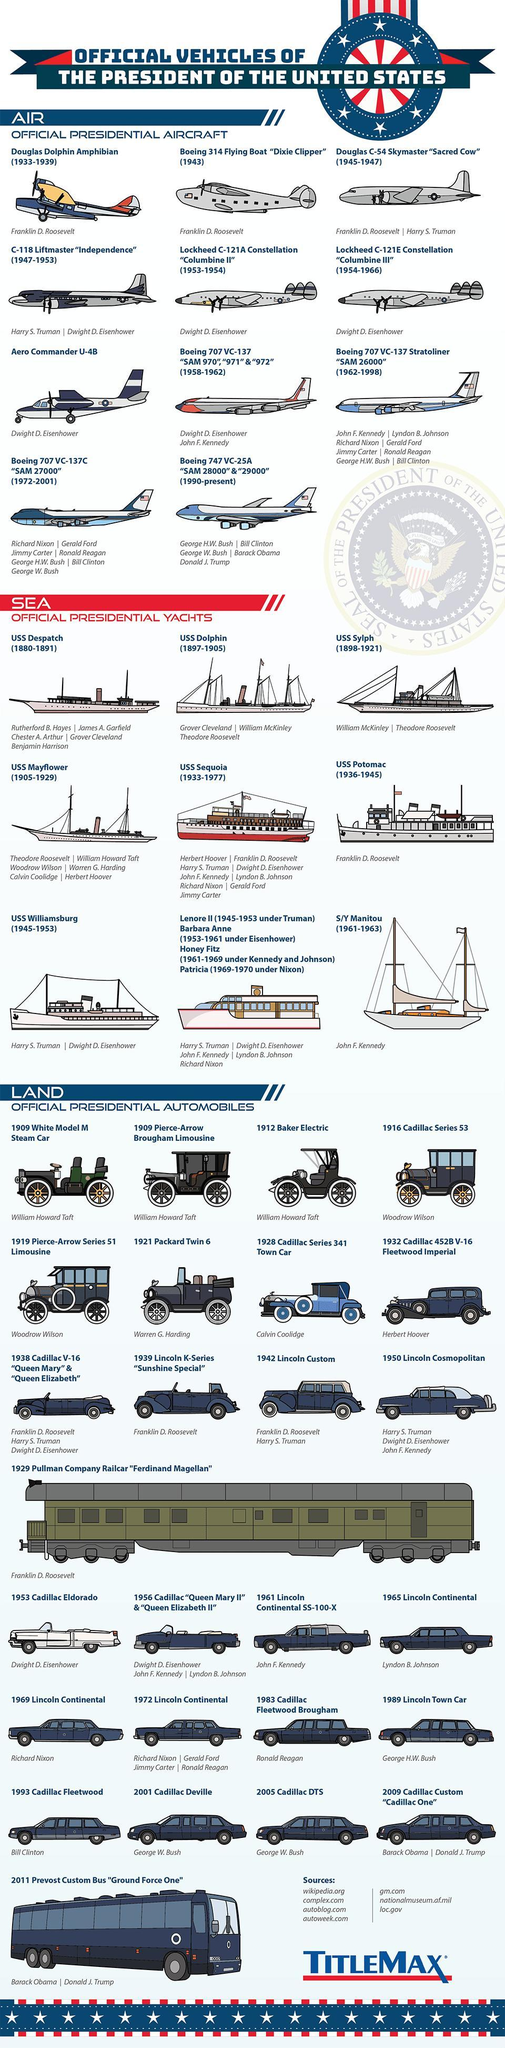Which yacht was shared by Harry S. Truman and Dwight D. Eisenhower?
Answer the question with a short phrase. USS Williamsburg Who used "Dixie Clipper"? Franklin D. Roosevelt Which is the aircraft in use currently? Boeing 747 VC-25A "SAM 28000" & "29000" What is the name of vehicle used by Barack Obama and Donald J Trump? 2009 Cadillac Custom "Cadillac One" Who last used USS Sequoia? Jimmy Carter What was John F Kennedy's presidential yacht called? S/Y Manitou Which was the first aircraft used by Dwight D. Eisenhower? C-118 Liftmaster "Independence" How many sources are listed? 7 Who used 1928 Cadillac Series 341 Town Car? Calvin Coolidge 